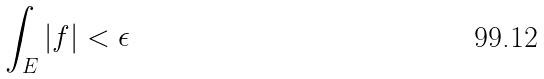Convert formula to latex. <formula><loc_0><loc_0><loc_500><loc_500>\int _ { E } | f | < \epsilon</formula> 